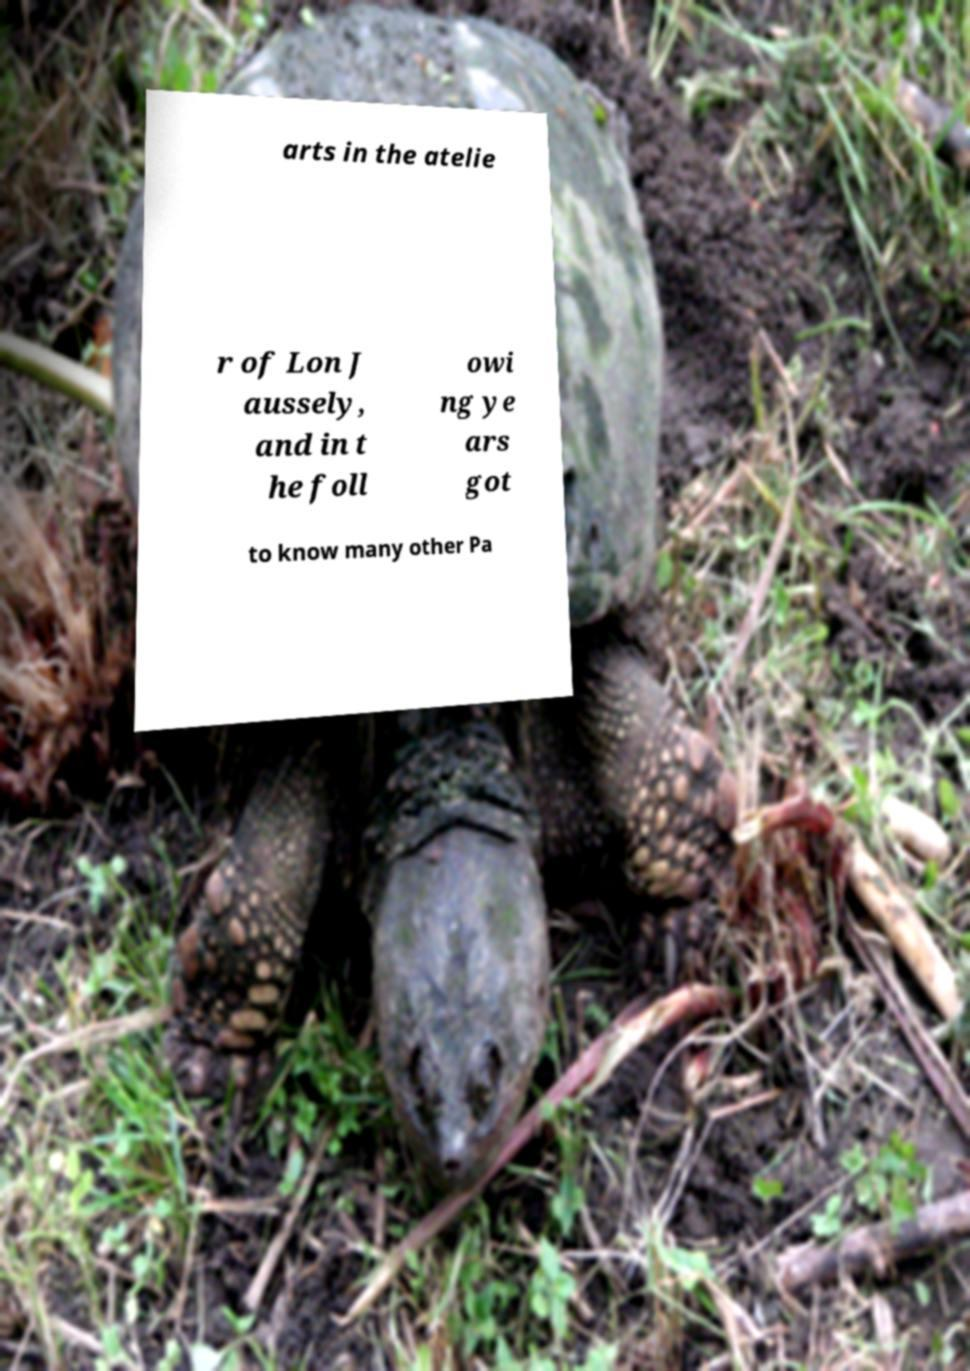I need the written content from this picture converted into text. Can you do that? arts in the atelie r of Lon J aussely, and in t he foll owi ng ye ars got to know many other Pa 